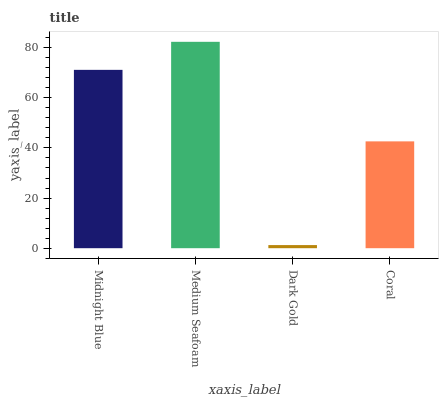Is Dark Gold the minimum?
Answer yes or no. Yes. Is Medium Seafoam the maximum?
Answer yes or no. Yes. Is Medium Seafoam the minimum?
Answer yes or no. No. Is Dark Gold the maximum?
Answer yes or no. No. Is Medium Seafoam greater than Dark Gold?
Answer yes or no. Yes. Is Dark Gold less than Medium Seafoam?
Answer yes or no. Yes. Is Dark Gold greater than Medium Seafoam?
Answer yes or no. No. Is Medium Seafoam less than Dark Gold?
Answer yes or no. No. Is Midnight Blue the high median?
Answer yes or no. Yes. Is Coral the low median?
Answer yes or no. Yes. Is Coral the high median?
Answer yes or no. No. Is Midnight Blue the low median?
Answer yes or no. No. 